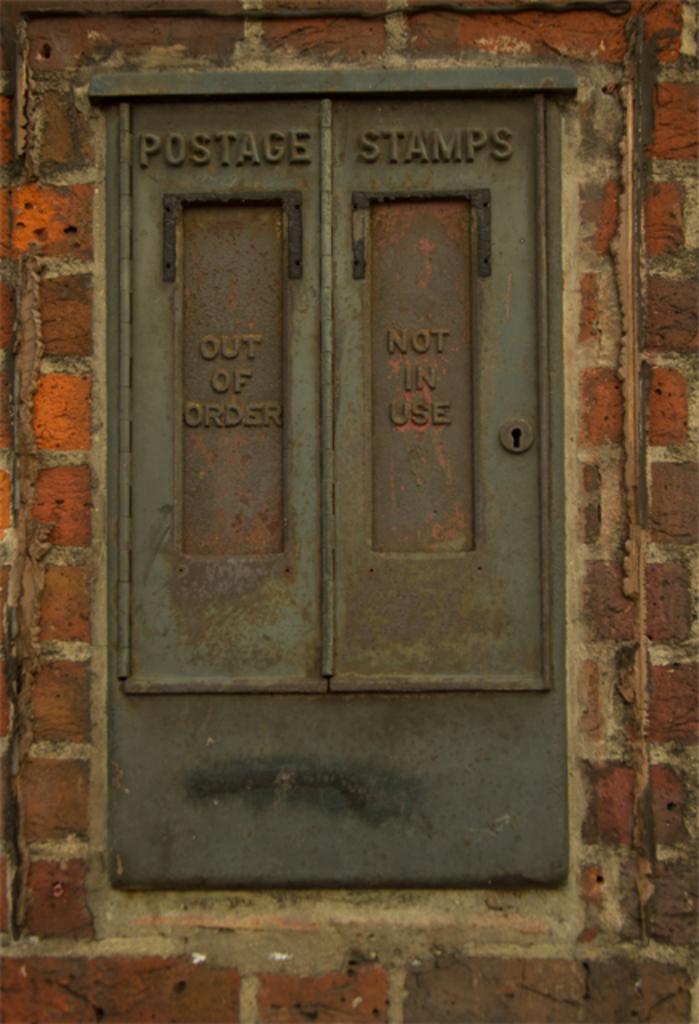Could you give a brief overview of what you see in this image? In this image we can see a window on a wall with some text on it. 